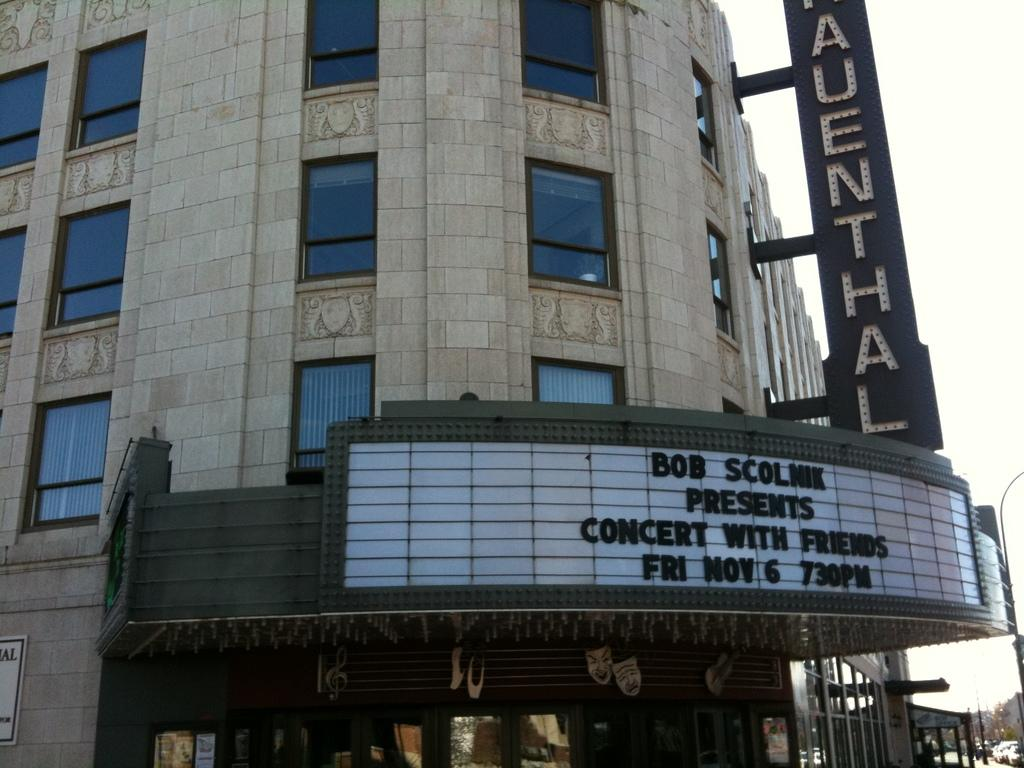What type of structure is present in the image? There is a building in the image. What feature can be seen on the building? The building has windows. What additional information can be gathered from the sign boards in the image? There are sign boards with text on them. What can be seen moving on the ground in the image? Vehicles are visible on the ground. What type of vegetation is present in the image? There are trees in the image. What other objects can be seen in the image? There are poles in the image. What is visible in the background of the image? The sky is visible in the image. What type of tooth is being used to hold the building in the image? There is no tooth present in the image; it is not holding the building. What type of beam is supporting the trees in the image? There is no beam supporting the trees in the image; they are standing on their own. 